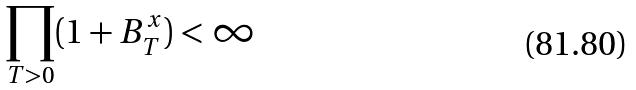Convert formula to latex. <formula><loc_0><loc_0><loc_500><loc_500>\prod _ { T > 0 } ( 1 + B _ { T } ^ { x } ) < \infty</formula> 